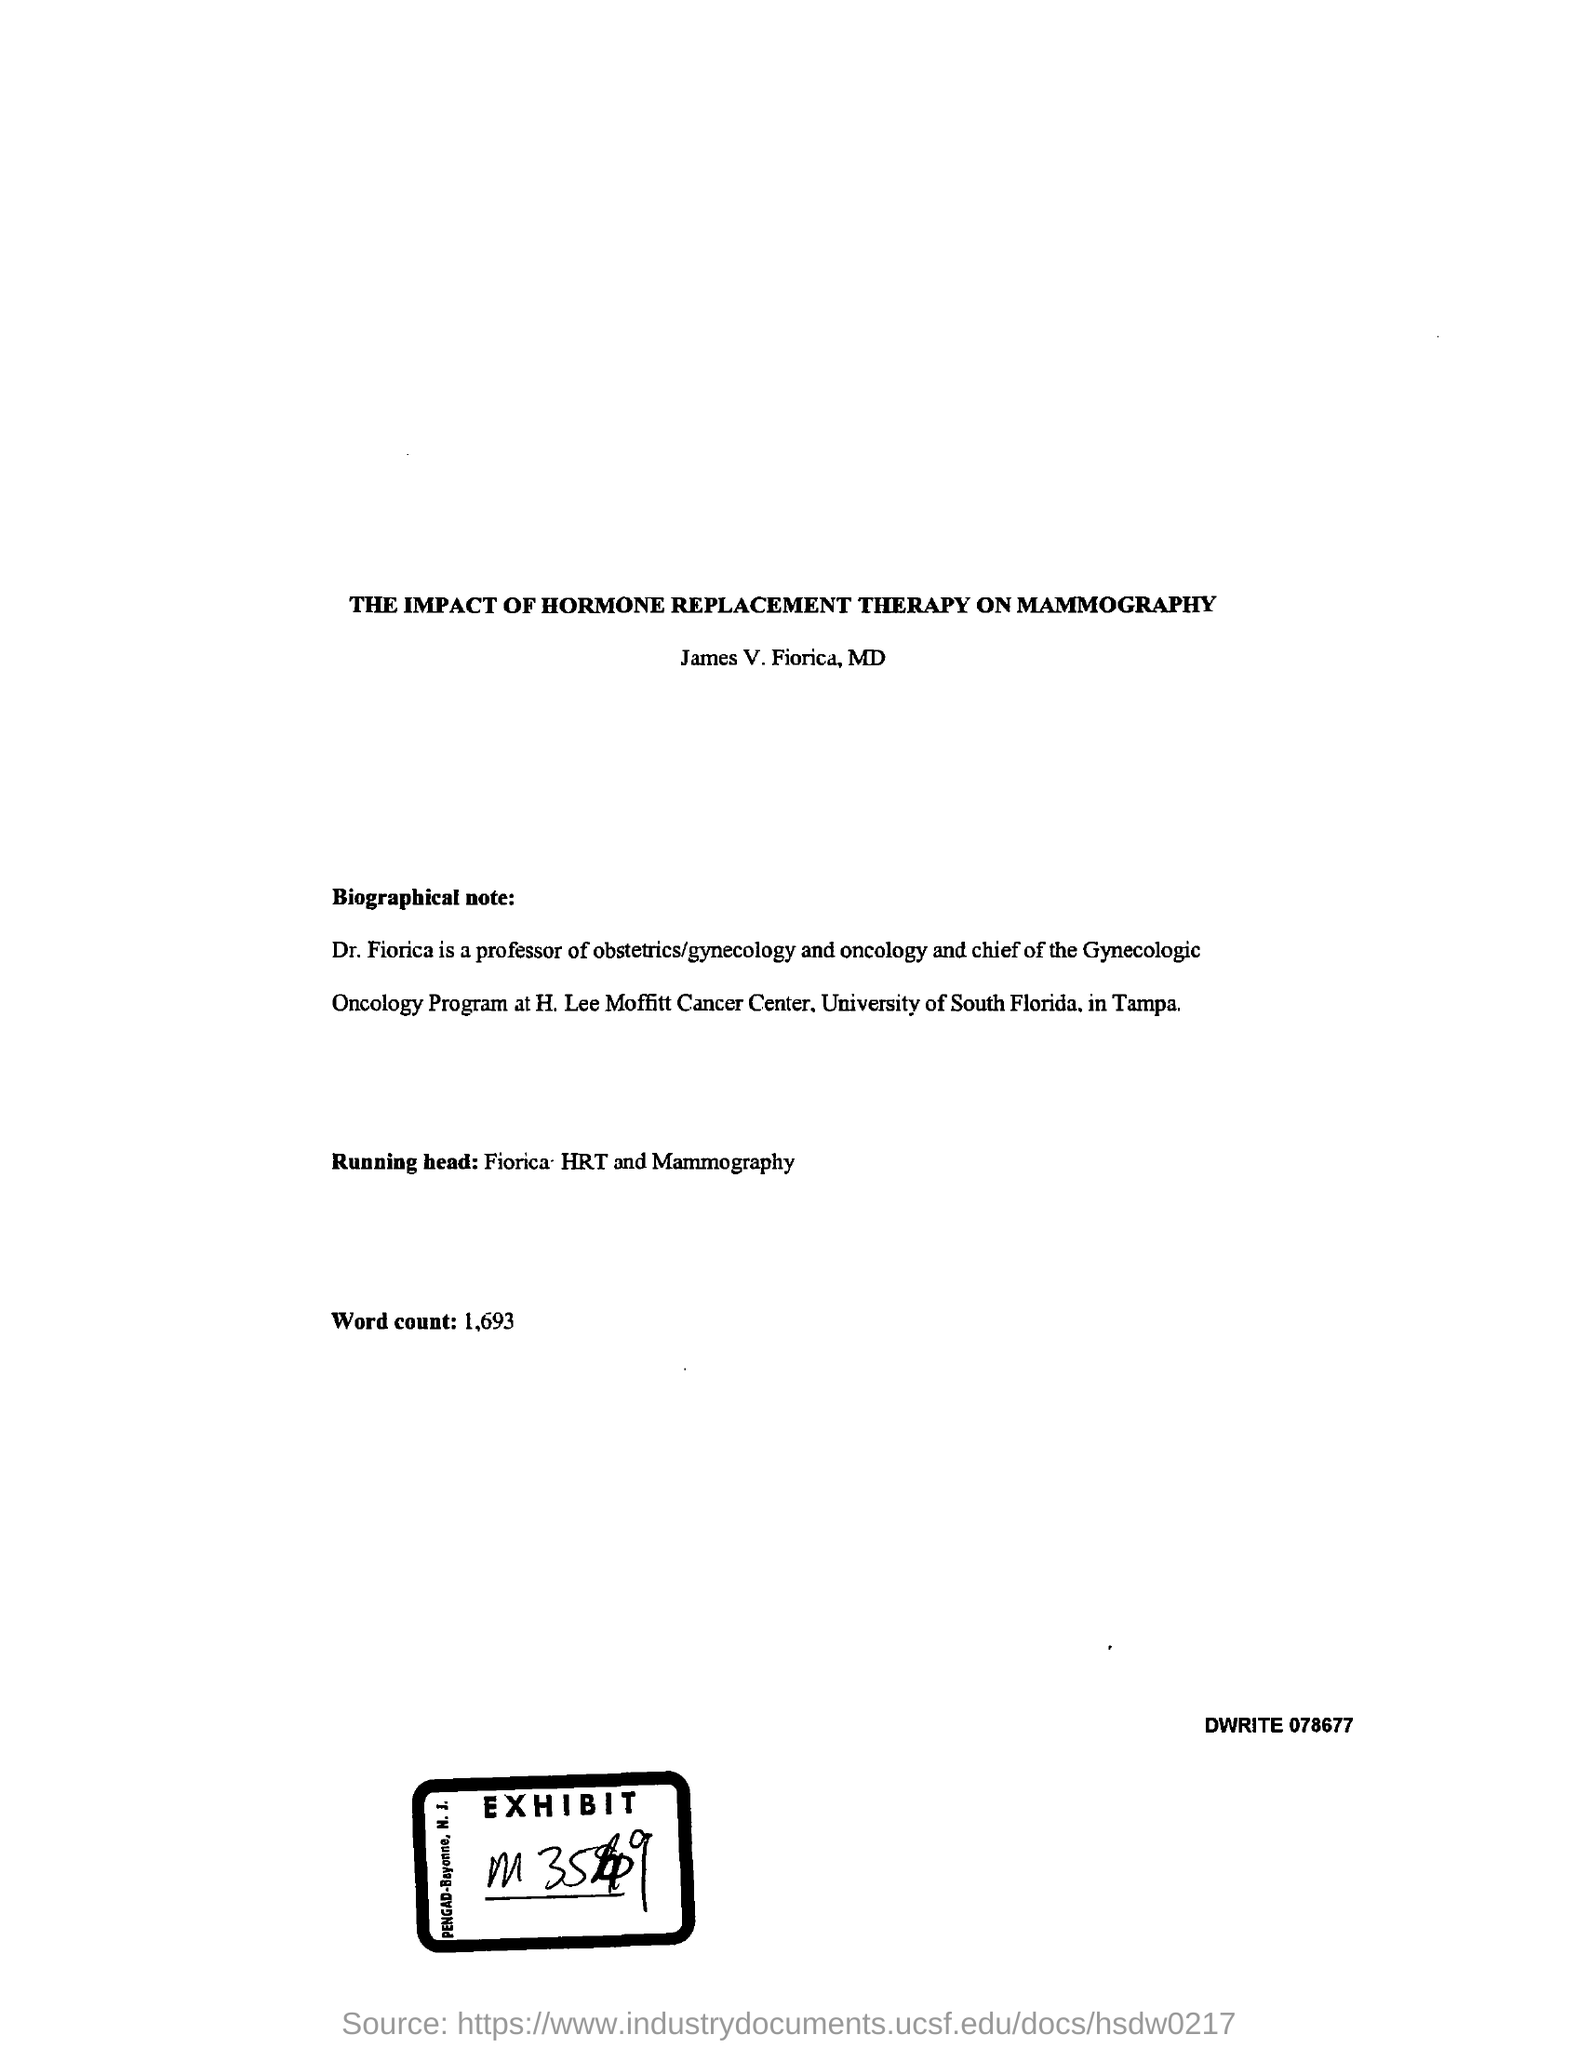Point out several critical features in this image. The word count is 1,693. The "running head" is a short title that is used as a header to identify a document or a section of a document. It is typically printed at the top of the page, just below the title page, and is typically shortened version of the title. For example, a running head for a document titled "The Benefits of Regular Exercise" may be "Regular Exercise. 